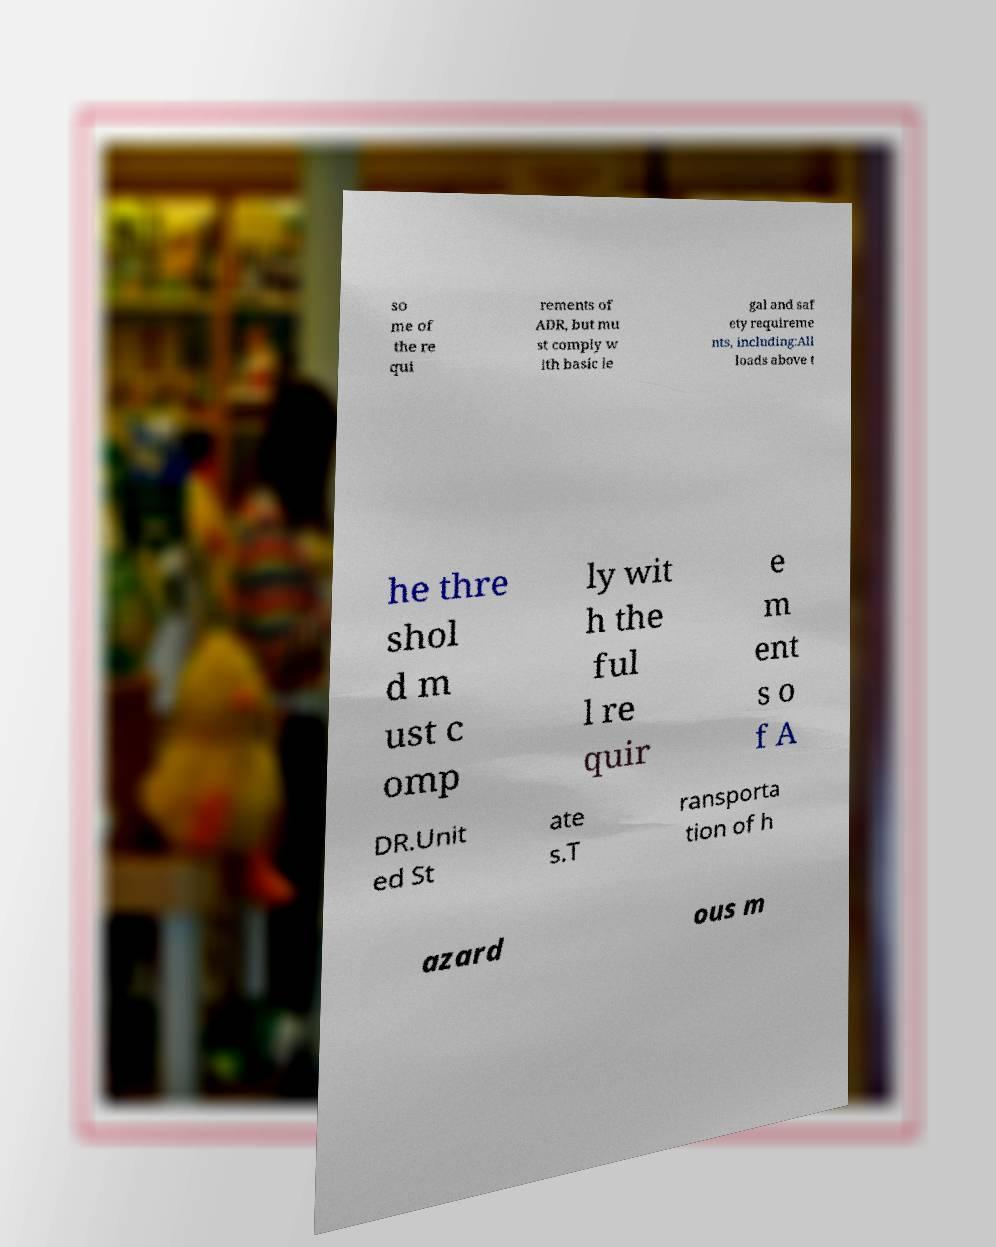Can you accurately transcribe the text from the provided image for me? so me of the re qui rements of ADR, but mu st comply w ith basic le gal and saf ety requireme nts, including:All loads above t he thre shol d m ust c omp ly wit h the ful l re quir e m ent s o f A DR.Unit ed St ate s.T ransporta tion of h azard ous m 